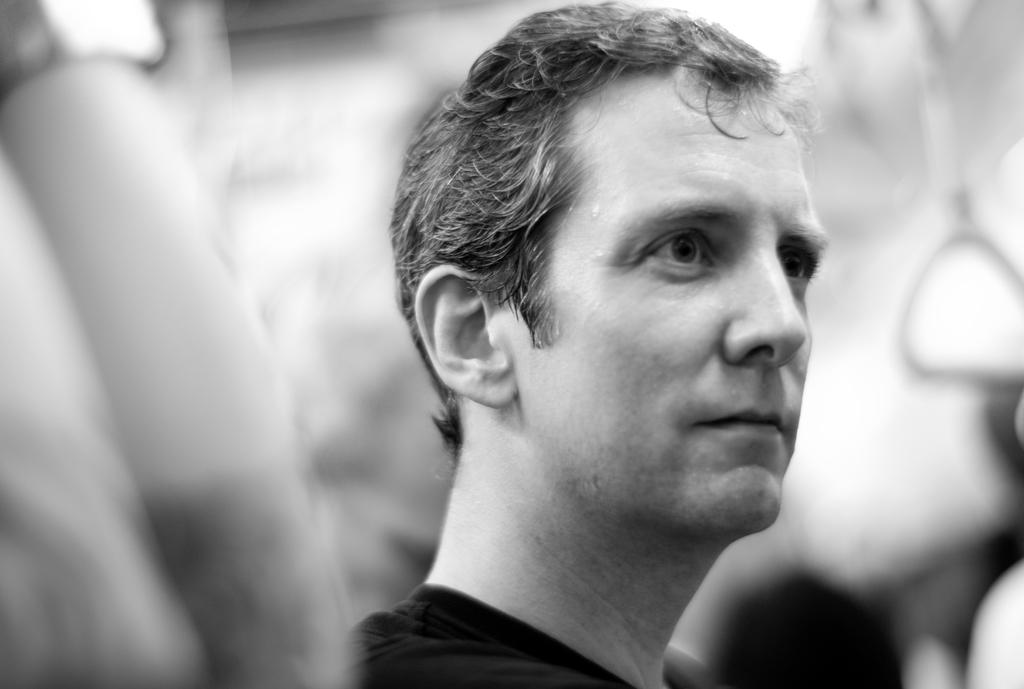Who is the main subject in the image? There is a man in the image. What is the color scheme of the image? The image is black and white in color. Can you describe the background of the image? The background of the image is blurry. How many ants can be seen on the man's apparel in the image? There are no ants visible on the man's apparel in the image. How many legs does the man have in the image? The man has two legs in the image, as is typical for humans. 